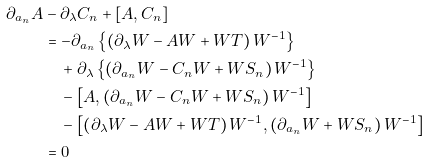Convert formula to latex. <formula><loc_0><loc_0><loc_500><loc_500>\partial _ { a _ { n } } A & - \partial _ { \lambda } C _ { n } + [ A , C _ { n } ] \\ & = - \partial _ { a _ { n } } \left \{ \left ( \partial _ { \lambda } W - A W + W T \right ) W ^ { - 1 } \right \} \\ & \quad + \partial _ { \lambda } \left \{ \left ( \partial _ { a _ { n } } W - C _ { n } W + W S _ { n } \right ) W ^ { - 1 } \right \} \\ & \quad - \left [ A , \left ( \partial _ { a _ { n } } W - C _ { n } W + W S _ { n } \right ) W ^ { - 1 } \right ] \\ & \quad - \left [ \left ( \partial _ { \lambda } W - A W + W T \right ) W ^ { - 1 } , \left ( \partial _ { a _ { n } } W + W S _ { n } \right ) W ^ { - 1 } \right ] \\ & = 0</formula> 